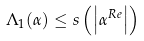<formula> <loc_0><loc_0><loc_500><loc_500>\Lambda _ { 1 } ( \alpha ) \leq s \left ( \left | \alpha ^ { R e } \right | \right )</formula> 